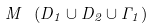Convert formula to latex. <formula><loc_0><loc_0><loc_500><loc_500>M \ ( D _ { 1 } \cup D _ { 2 } \cup \Gamma _ { 1 } )</formula> 